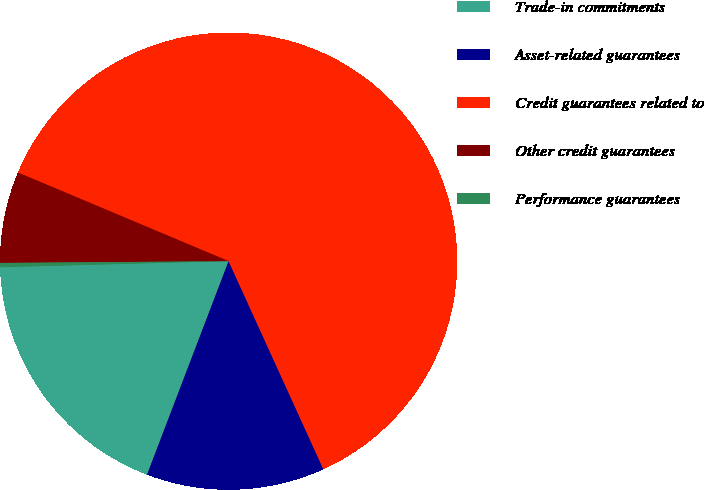<chart> <loc_0><loc_0><loc_500><loc_500><pie_chart><fcel>Trade-in commitments<fcel>Asset-related guarantees<fcel>Credit guarantees related to<fcel>Other credit guarantees<fcel>Performance guarantees<nl><fcel>18.77%<fcel>12.61%<fcel>61.86%<fcel>6.46%<fcel>0.3%<nl></chart> 